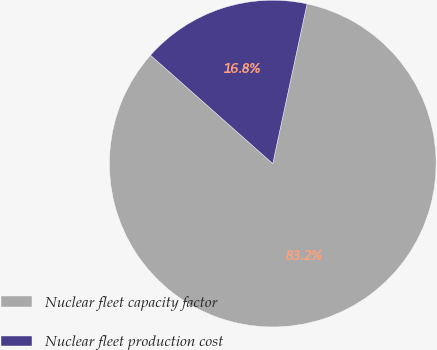Convert chart to OTSL. <chart><loc_0><loc_0><loc_500><loc_500><pie_chart><fcel>Nuclear fleet capacity factor<fcel>Nuclear fleet production cost<nl><fcel>83.18%<fcel>16.82%<nl></chart> 